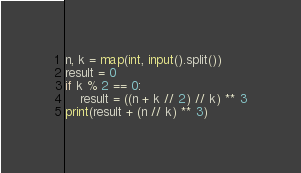Convert code to text. <code><loc_0><loc_0><loc_500><loc_500><_Python_>n, k = map(int, input().split())
result = 0
if k % 2 == 0:
    result = ((n + k // 2) // k) ** 3
print(result + (n // k) ** 3)</code> 